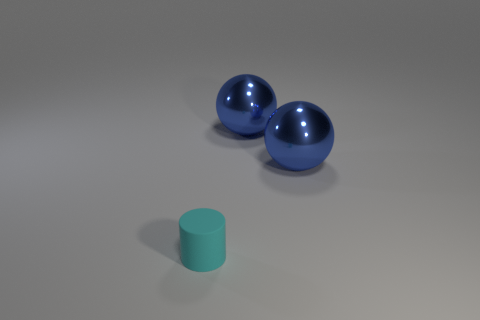How many things are either objects that are behind the small rubber thing or cyan cylinders?
Provide a short and direct response. 3. Is there another small object of the same color as the tiny object?
Ensure brevity in your answer.  No. Are there any large spheres?
Your answer should be very brief. Yes. Is there another cyan matte cylinder of the same size as the cyan matte cylinder?
Make the answer very short. No. What is the color of the cylinder?
Make the answer very short. Cyan. Are there more big spheres that are to the right of the matte object than brown metallic balls?
Your response must be concise. Yes. There is a tiny object; how many big things are to the left of it?
Provide a succinct answer. 0. Is the number of rubber objects that are behind the tiny cyan matte cylinder the same as the number of large metal objects?
Make the answer very short. No. What number of other things are there of the same material as the cyan object
Provide a succinct answer. 0. How many things are things that are right of the cyan rubber cylinder or objects right of the cyan thing?
Ensure brevity in your answer.  2. 